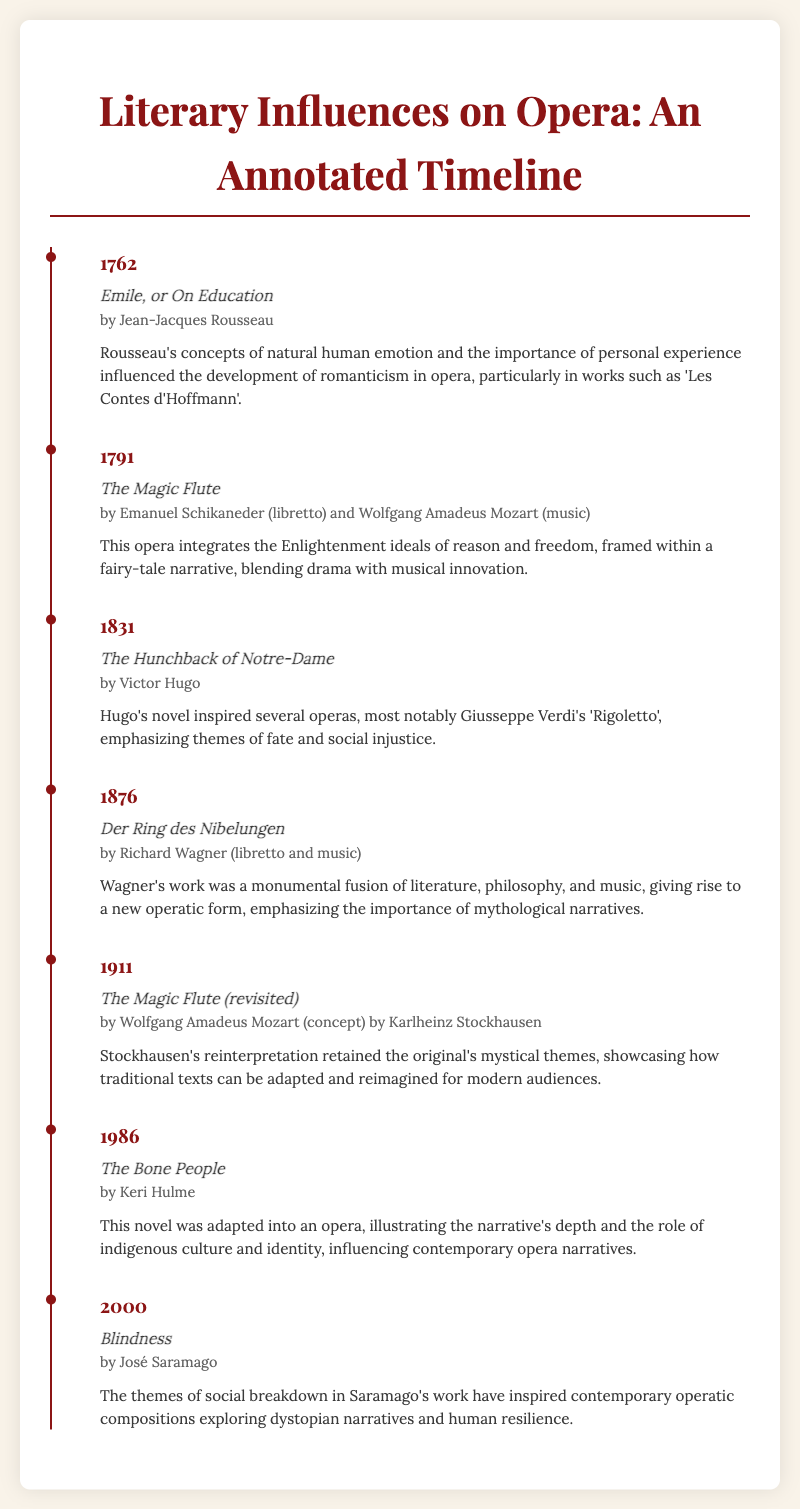What is the title of the first literary work listed? The first literary work listed is presented in the timeline as "Emile, or On Education."
Answer: Emile, or On Education Who wrote "The Hunchback of Notre-Dame"? The author of "The Hunchback of Notre-Dame" is Victor Hugo.
Answer: Victor Hugo In what year was "Der Ring des Nibelungen" published? The year given for the publication of "Der Ring des Nibelungen" is 1876.
Answer: 1876 What is a theme emphasized in Verdi's "Rigoletto"? The theme emphasized in Verdi's "Rigoletto" is social injustice.
Answer: social injustice Which opera was adapted from Keri Hulme's novel? The opera adapted from Keri Hulme's novel is "The Bone People."
Answer: The Bone People How does Stockhausen's reinterpretation of "The Magic Flute" relate to the original? Stockhausen's reinterpretation retained the mystical themes of the original work.
Answer: retained the original's mystical themes What literary movement did Rousseau influence in opera? Rousseau's work influenced the development of romanticism in opera.
Answer: romanticism What narrative theme is explored in José Saramago's "Blindness"? The theme explored in "Blindness" is social breakdown.
Answer: social breakdown 